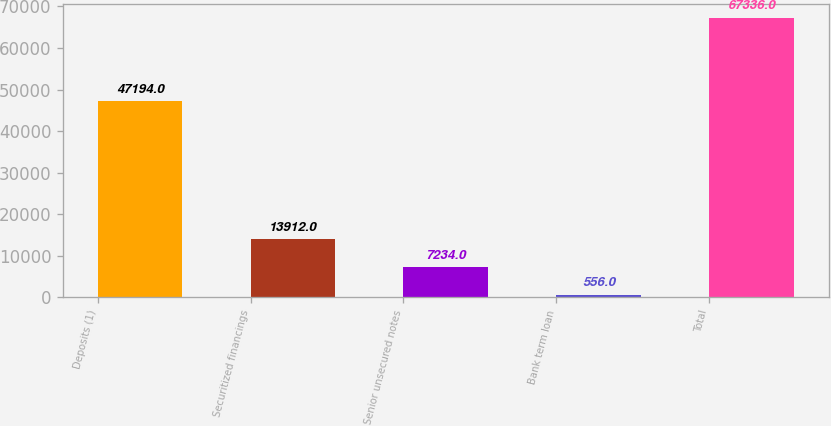Convert chart. <chart><loc_0><loc_0><loc_500><loc_500><bar_chart><fcel>Deposits (1)<fcel>Securitized financings<fcel>Senior unsecured notes<fcel>Bank term loan<fcel>Total<nl><fcel>47194<fcel>13912<fcel>7234<fcel>556<fcel>67336<nl></chart> 